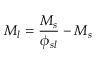Convert formula to latex. <formula><loc_0><loc_0><loc_500><loc_500>M _ { l } = { \frac { M _ { s } } { \phi _ { s l } } } - M _ { s }</formula> 